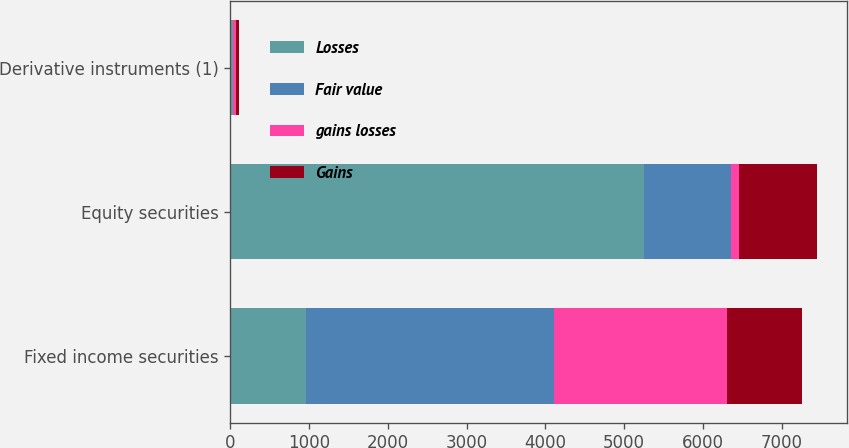<chart> <loc_0><loc_0><loc_500><loc_500><stacked_bar_chart><ecel><fcel>Fixed income securities<fcel>Equity securities<fcel>Derivative instruments (1)<nl><fcel>Losses<fcel>956<fcel>5257<fcel>33<nl><fcel>Fair value<fcel>3151<fcel>1096<fcel>4<nl><fcel>gains losses<fcel>2195<fcel>106<fcel>37<nl><fcel>Gains<fcel>956<fcel>990<fcel>33<nl></chart> 